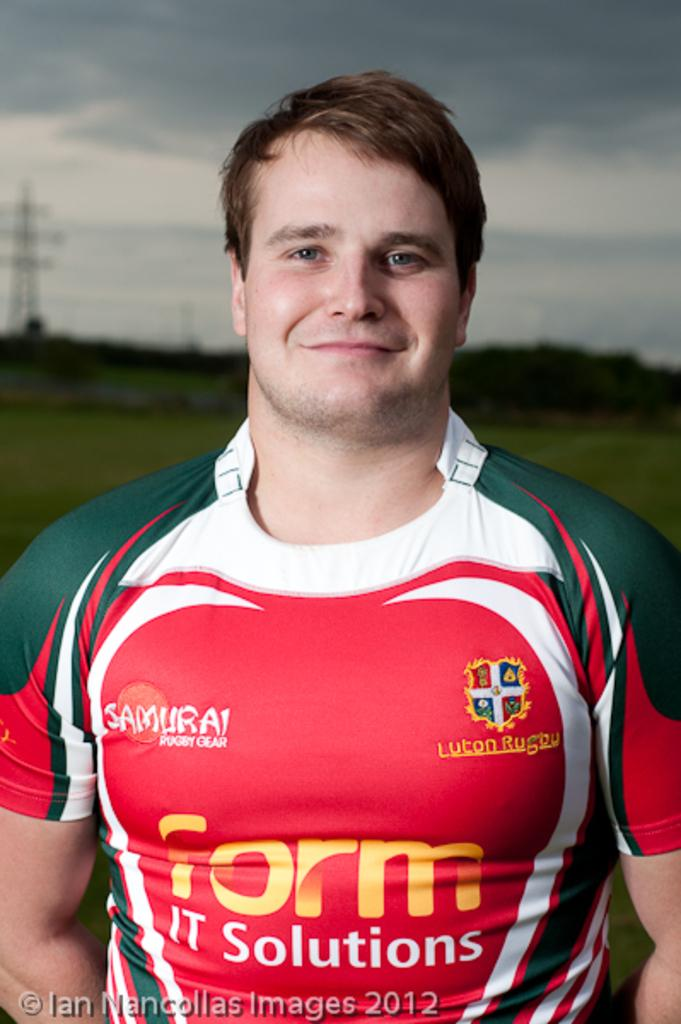<image>
Render a clear and concise summary of the photo. A player from Luton Rugby is pictured in his jersey. 